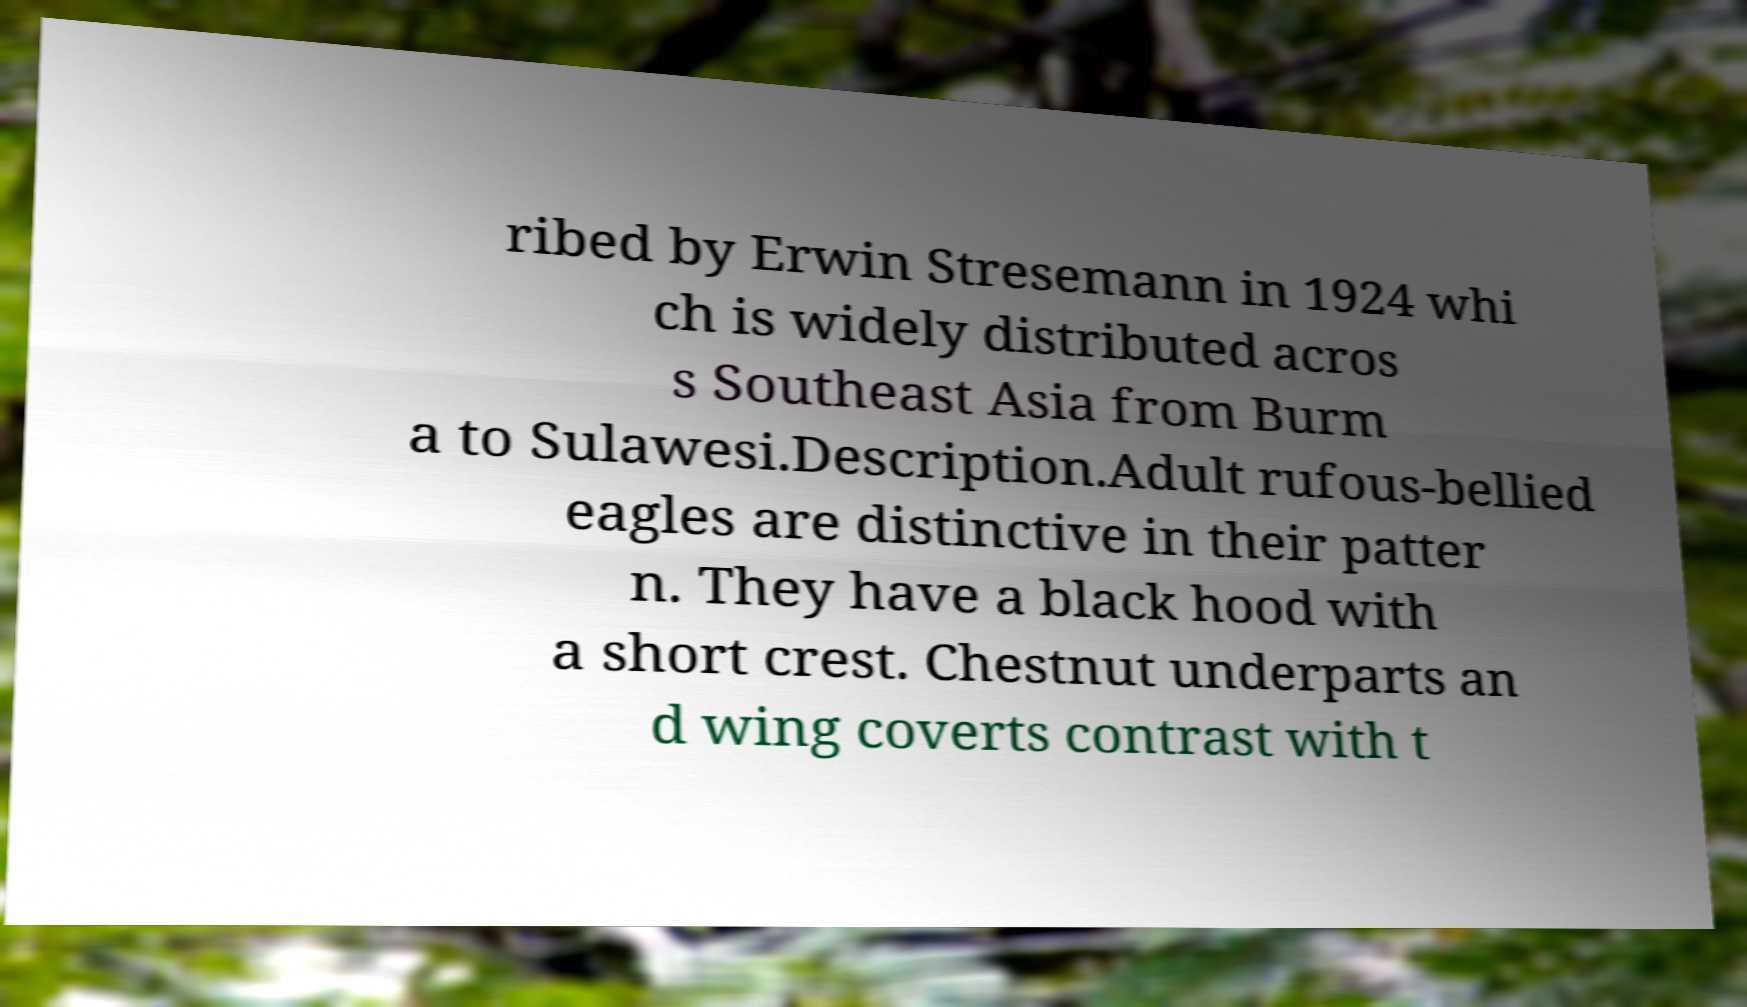Could you extract and type out the text from this image? ribed by Erwin Stresemann in 1924 whi ch is widely distributed acros s Southeast Asia from Burm a to Sulawesi.Description.Adult rufous-bellied eagles are distinctive in their patter n. They have a black hood with a short crest. Chestnut underparts an d wing coverts contrast with t 